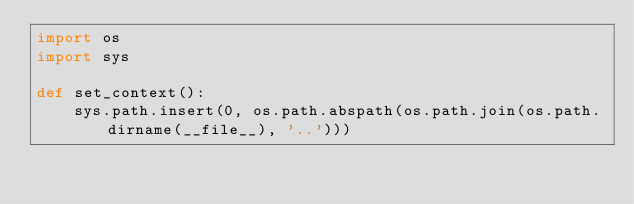<code> <loc_0><loc_0><loc_500><loc_500><_Python_>import os
import sys

def set_context():
    sys.path.insert(0, os.path.abspath(os.path.join(os.path.dirname(__file__), '..')))
</code> 